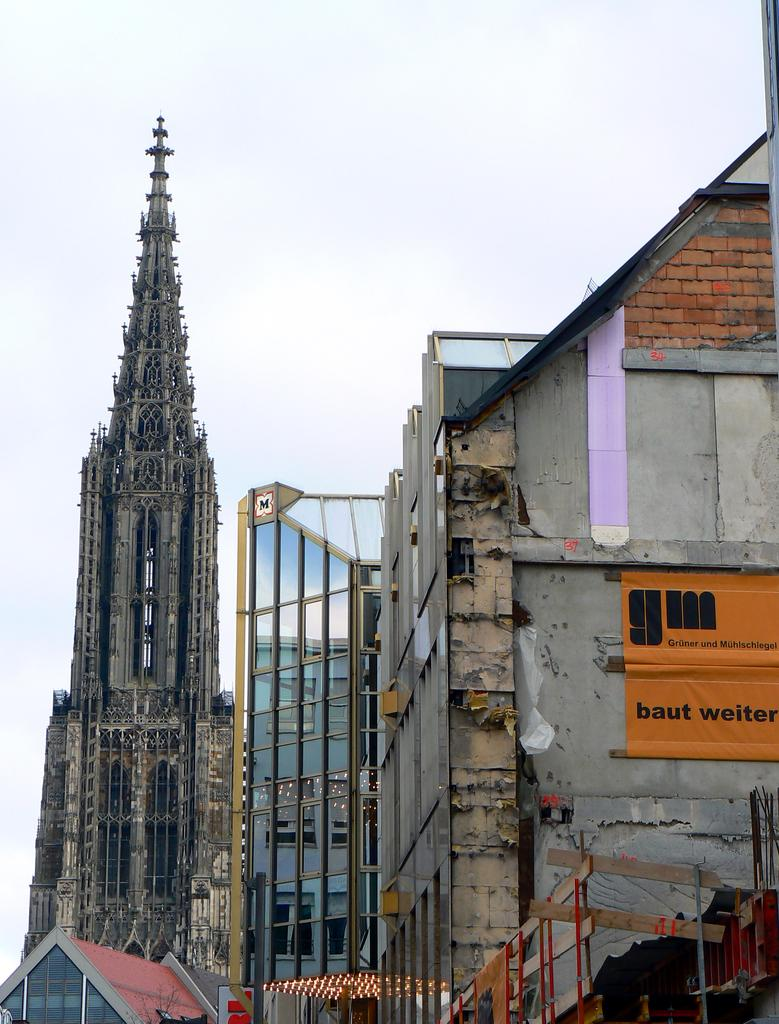What type of structures are present in the image? There are buildings and a tower in the image. What can be seen at the top of the image? The sky is visible at the top of the image. What is attached to one of the buildings in the image? There is a banner on a building in the image. What type of food is being cooked on the tower in the image? There is no food or cooking activity present in the image; the tower is a structure. 